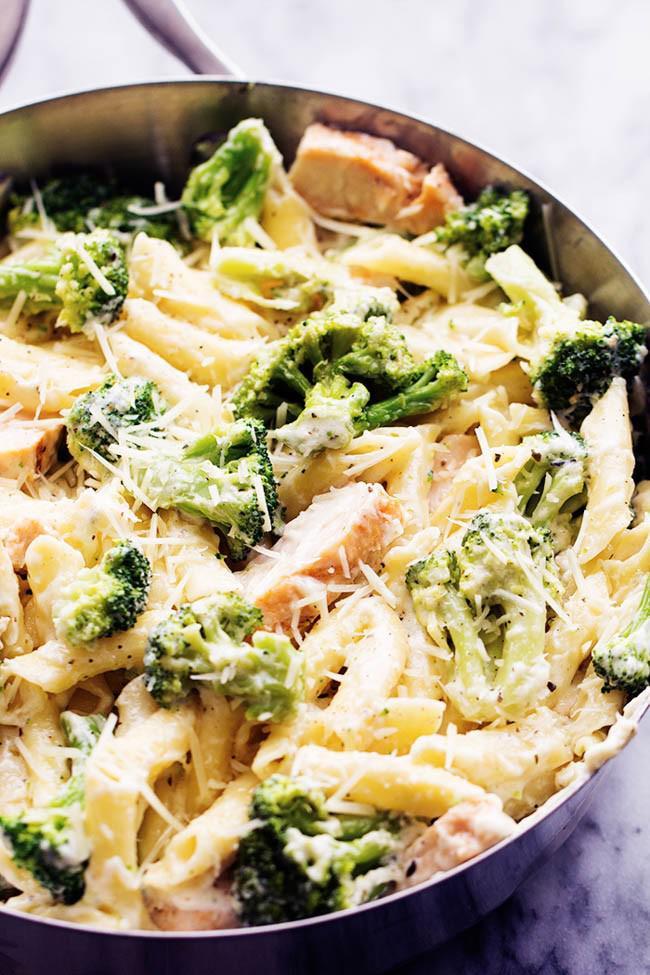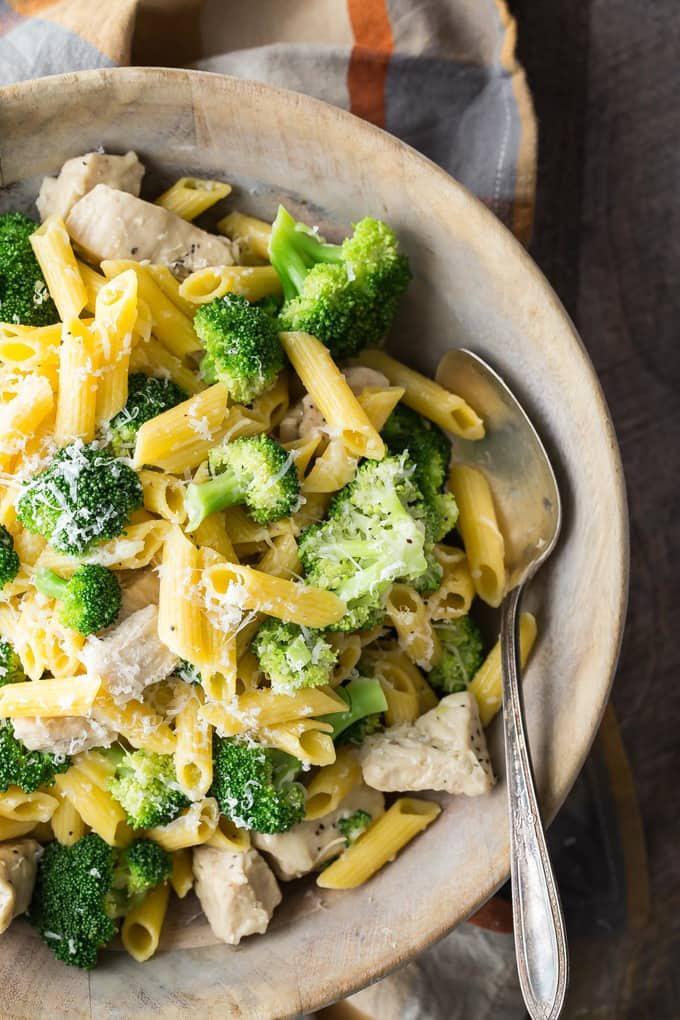The first image is the image on the left, the second image is the image on the right. For the images displayed, is the sentence "The bowl in the image on the left is white and round." factually correct? Answer yes or no. No. The first image is the image on the left, the second image is the image on the right. Evaluate the accuracy of this statement regarding the images: "An image shows a round bowl of broccoli and pasta with a silver serving spoon inserted in it.". Is it true? Answer yes or no. Yes. 